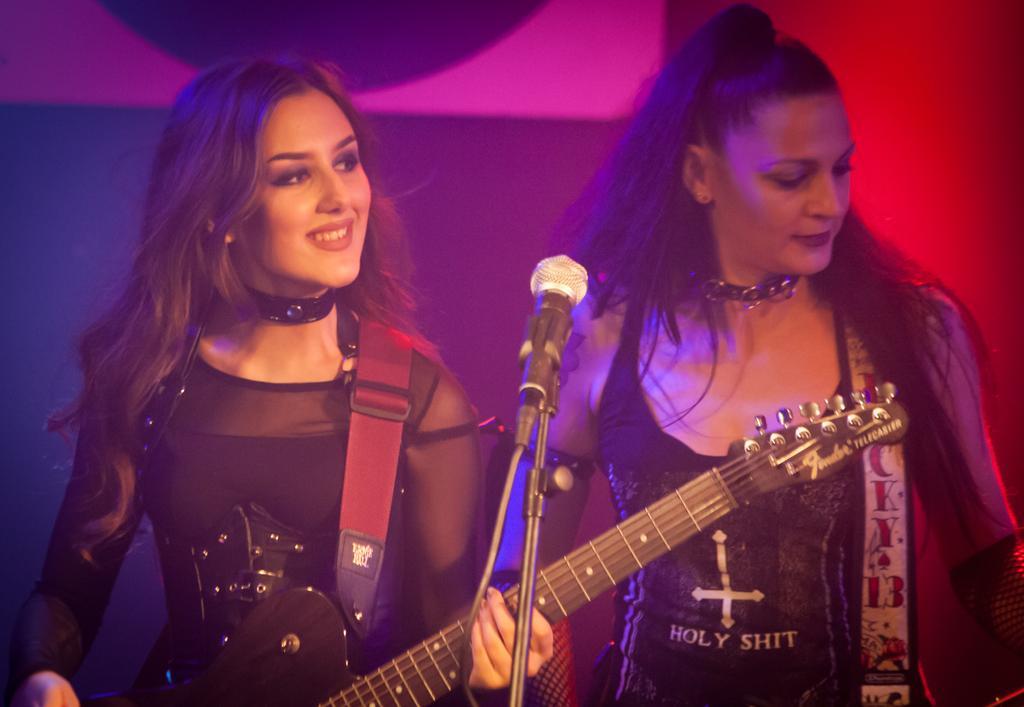Could you give a brief overview of what you see in this image? In this picture we can see two women holding guitars with their hands and smiling and in front of them we can see a mic. 